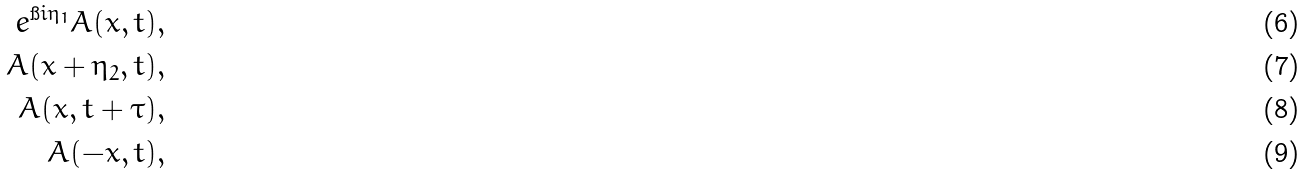<formula> <loc_0><loc_0><loc_500><loc_500>\ e ^ { \i i \eta _ { 1 } } A ( x , t ) & , \\ A ( x + \eta _ { 2 } , t ) & , \\ A ( x , t + \tau ) & , \\ A ( - x , t ) & ,</formula> 